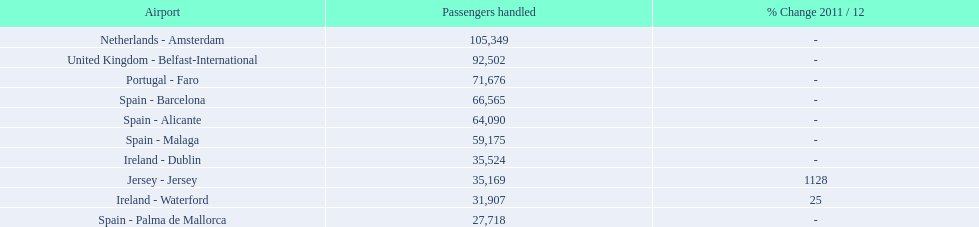What is the highest number of passengers handled? 105,349. What is the destination of the passengers leaving the area that handles 105,349 travellers? Netherlands - Amsterdam. 